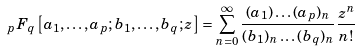Convert formula to latex. <formula><loc_0><loc_0><loc_500><loc_500>\ _ { p } F _ { q } \left [ a _ { 1 } , \dots , a _ { p } ; b _ { 1 } , \dots , b _ { q } ; z \right ] = \sum _ { n = 0 } ^ { \infty } \frac { ( a _ { 1 } ) \dots ( a _ { p } ) _ { n } } { ( b _ { 1 } ) _ { n } \dots ( b _ { q } ) _ { n } } \frac { z ^ { n } } { n ! }</formula> 